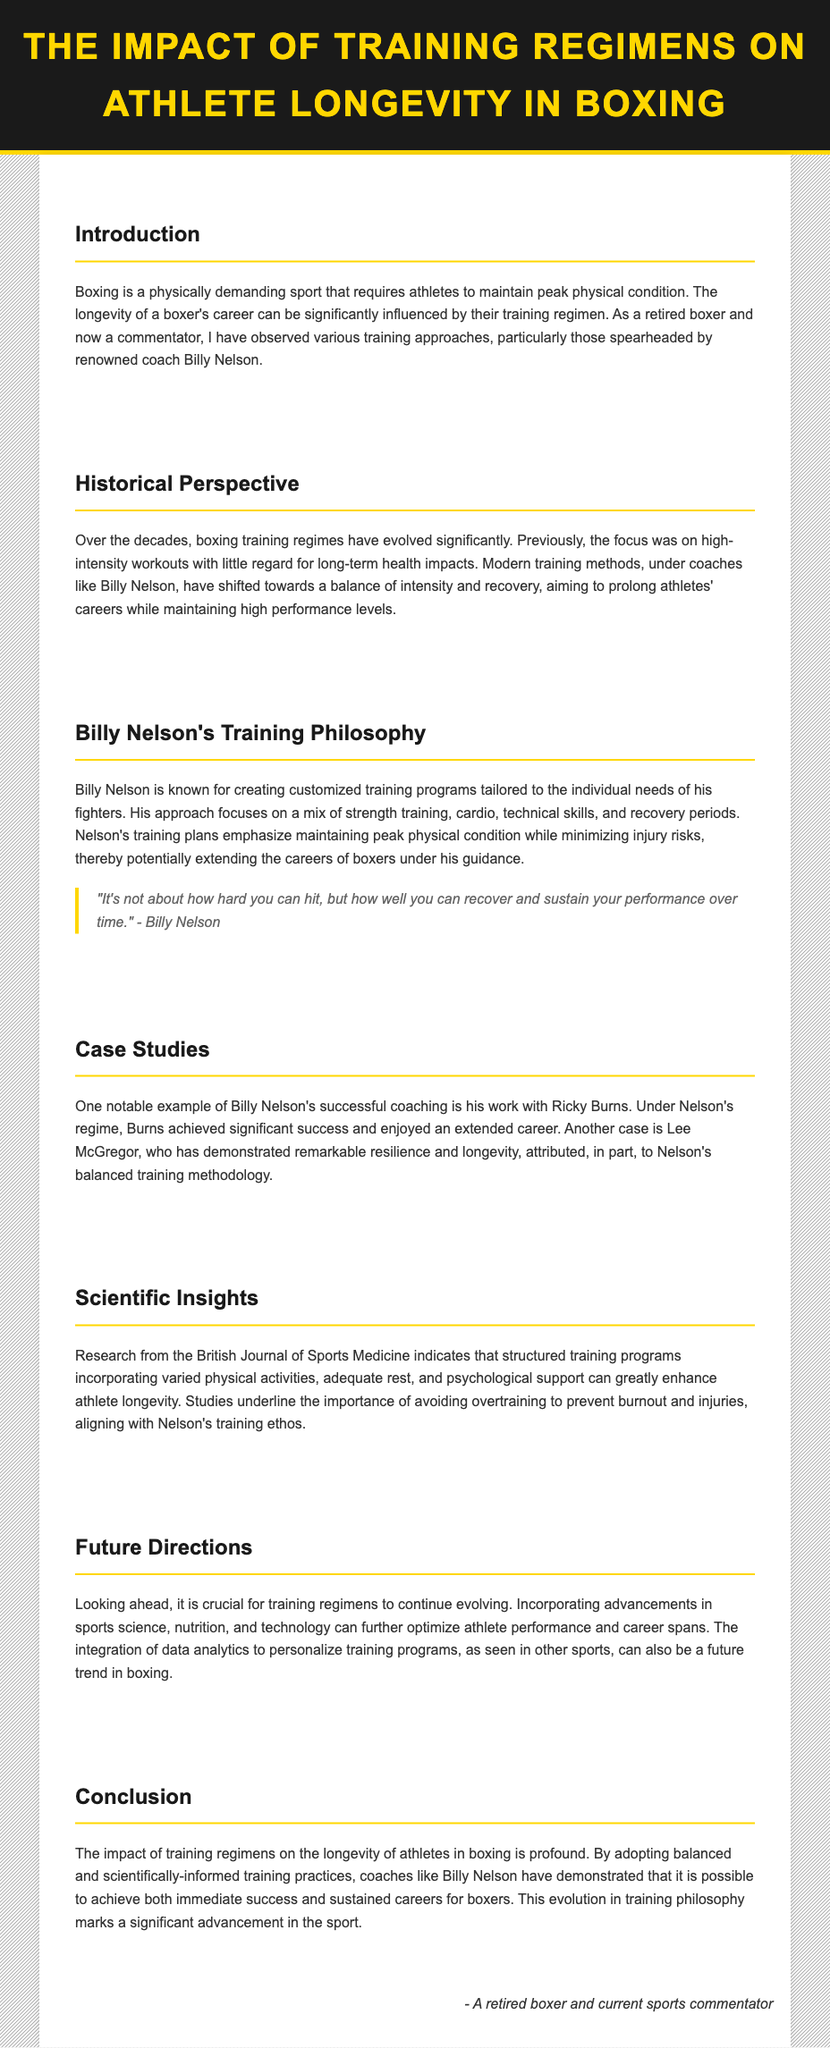What is the title of the document? The title is stated in the header of the document, which is "The Impact of Training Regimens on Athlete Longevity in Boxing."
Answer: The Impact of Training Regimens on Athlete Longevity in Boxing Who is a notable boxer mentioned in case studies? The document refers to several boxers, including Ricky Burns who is highlighted for his success under Billy Nelson's coaching.
Answer: Ricky Burns What is Billy Nelson's training emphasis? The document indicates that Nelson focuses on a mix of strength training, cardio, technical skills, and recovery periods.
Answer: A mix of strength training, cardio, technical skills, and recovery periods Which journal provides scientific insights mentioned in the document? The document specifies that research findings come from the British Journal of Sports Medicine, indicating the credibility and relevance of the cited research.
Answer: British Journal of Sports Medicine What does the quote from Billy Nelson focus on? The quote discusses the importance of recovery and sustaining performance, which aligns with the document's theme of longevity in boxing.
Answer: Recovery and sustaining performance What have modern training methods shifted towards? The document states that modern training methods focus on a balance of intensity and recovery aiming to prolong athletes' careers while maintaining performance levels.
Answer: A balance of intensity and recovery How does the document describe the evolution of training regimes? It illustrates that training regimes have undergone significant changes, moving from high intensity with little regard for long-term health to more balanced approaches.
Answer: Significant changes What is a future direction suggested in the document? The document suggests that training regimens should continue evolving by incorporating advancements in sports science, nutrition, and technology.
Answer: Advancements in sports science, nutrition, and technology 